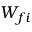<formula> <loc_0><loc_0><loc_500><loc_500>W _ { f i }</formula> 